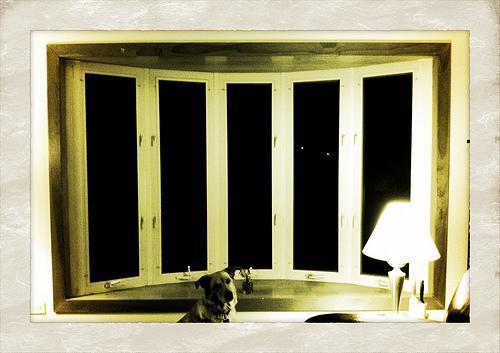How many lamps are there?
Give a very brief answer. 1. How many window panes are there?
Give a very brief answer. 5. 